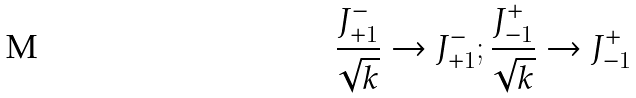<formula> <loc_0><loc_0><loc_500><loc_500>\frac { J _ { + 1 } ^ { - } } { \sqrt { k } } \rightarrow J _ { + 1 } ^ { - } ; \frac { J _ { - 1 } ^ { + } } { \sqrt { k } } \rightarrow J _ { - 1 } ^ { + }</formula> 